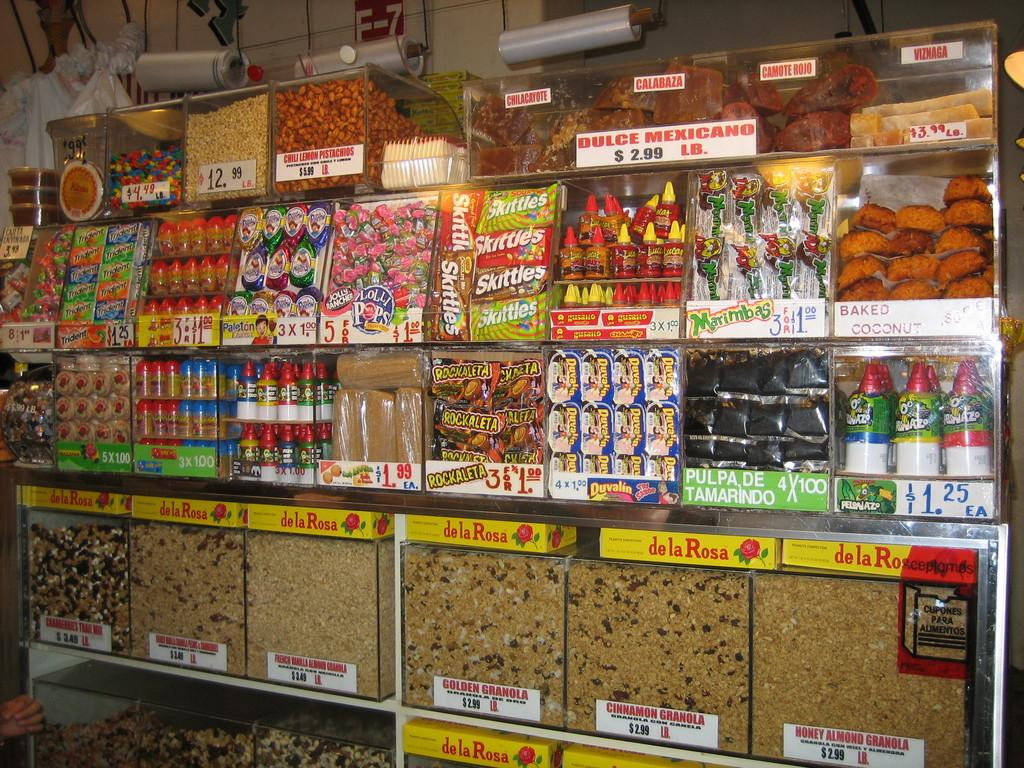What type of containers are used to store food items in the image? The food items are stored in glass containers in the image. What can be seen on the glass containers? There is text printed on each of the containers. Can you describe anything visible in the background of the image? There are plastic rollers visible in the background of the image. How many geese are sitting on the cake in the image? There are no geese or cake present in the image; it features glass containers with text and plastic rollers in the background. 